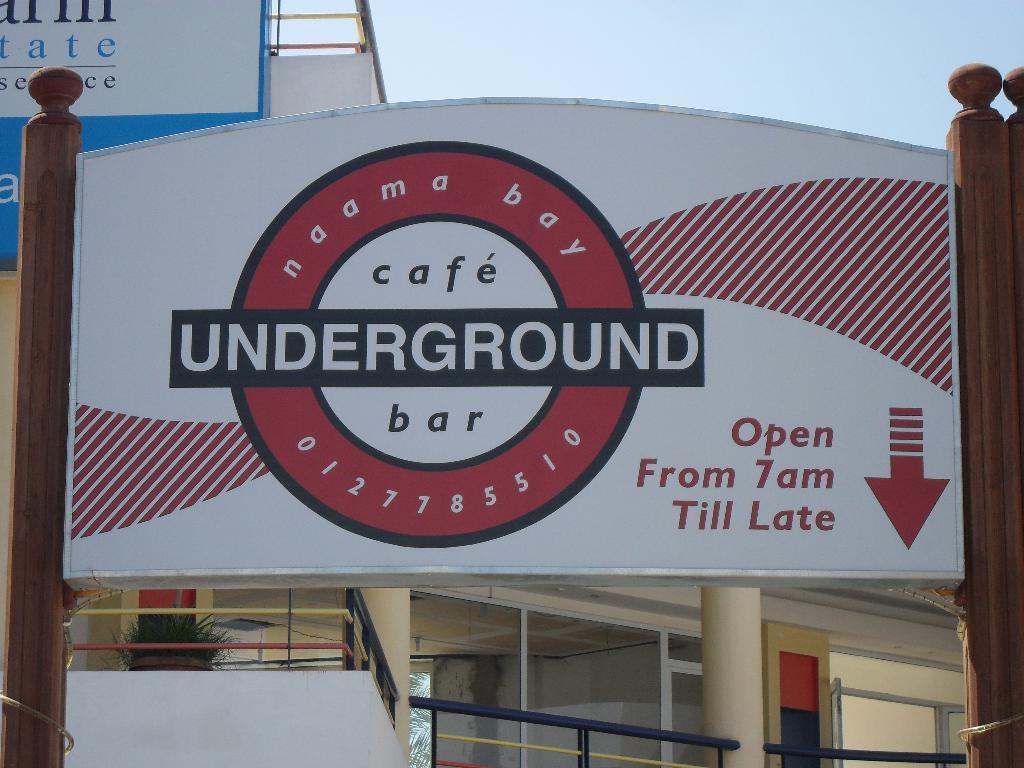Could you give a brief overview of what you see in this image? In this image I can see wooden poles with a board. In the background there is a building, there is another board, there are pillars and there is sky. 